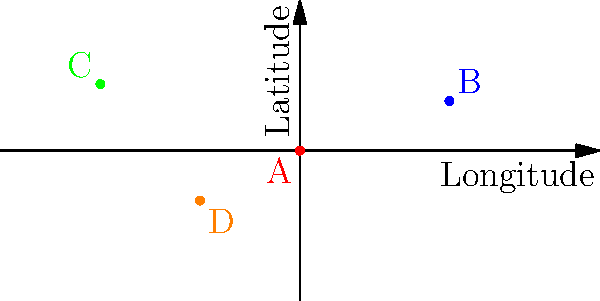A world map is represented as a coordinate system with longitude on the x-axis (-180° to 180°) and latitude on the y-axis (-90° to 90°). Four points A, B, C, and D represent locations of minority language speakers. Which point represents a language spoken in South America? To determine which point represents a language spoken in South America, we need to analyze the coordinates of each point and their corresponding geographical locations:

1. Point A: (0, 0) - This is at the intersection of the Prime Meridian and the Equator, likely in the Atlantic Ocean or West Africa.
2. Point B: (90, 30) - This is in Asia, possibly in China or Mongolia.
3. Point C: (-120, 40) - This is in North America, possibly in the western United States or Canada.
4. Point D: (-60, -30) - This is in South America, likely in Argentina or Chile.

South America is generally located in the Western Hemisphere (negative longitude) and primarily in the Southern Hemisphere (negative latitude). Among the given points, only Point D satisfies these conditions.

Therefore, Point D represents a language spoken in South America.
Answer: Point D 